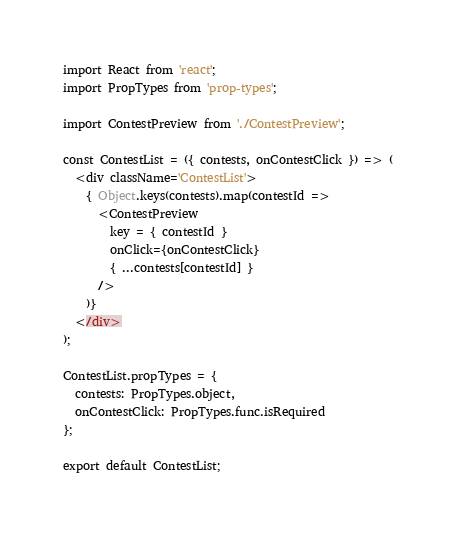<code> <loc_0><loc_0><loc_500><loc_500><_JavaScript_>import React from 'react';
import PropTypes from 'prop-types';

import ContestPreview from './ContestPreview';

const ContestList = ({ contests, onContestClick }) => (
  <div className='ContestList'>
    { Object.keys(contests).map(contestId =>
      <ContestPreview
        key = { contestId }
        onClick={onContestClick}
        { ...contests[contestId] }
      />
    )}
  </div>
);

ContestList.propTypes = {
  contests: PropTypes.object,
  onContestClick: PropTypes.func.isRequired
};

export default ContestList;
</code> 